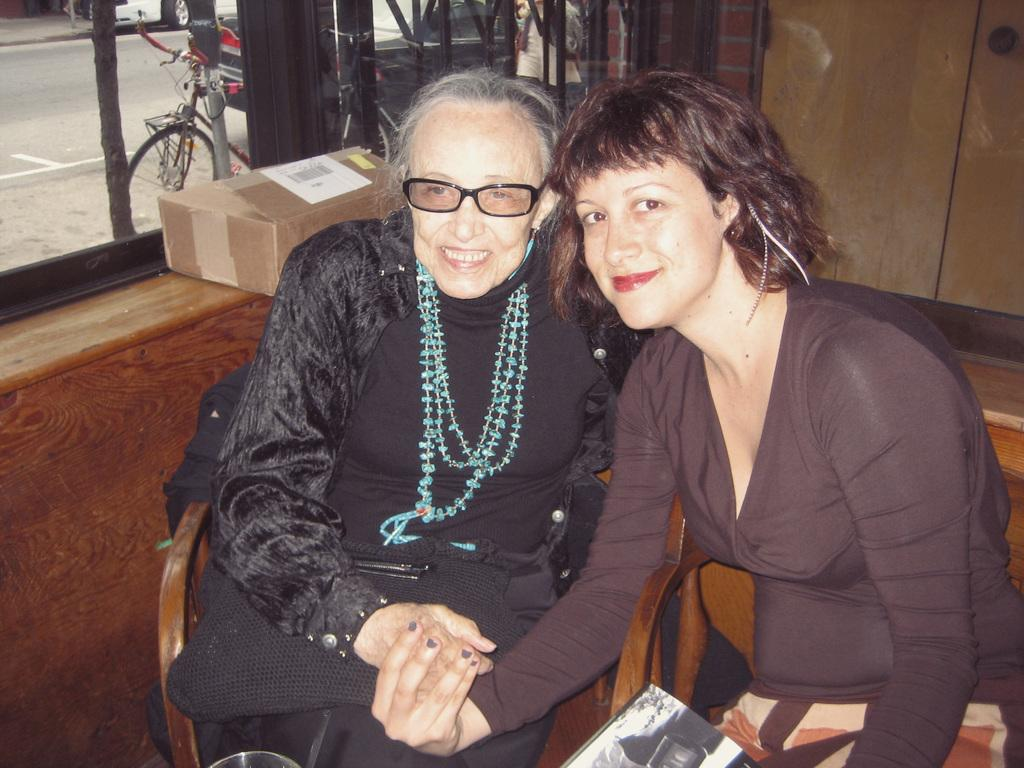How many women are in the image? There are two women in the foreground of the image. What is located behind the women? There is a cupboard behind the women. Where is the window in the image? The window is on the left side of the image. What can be seen outside the window? Vehicles are visible behind the window. What type of wrench is being used by one of the women in the image? There is no wrench present in the image; both women are simply standing in the foreground. Does the existence of the window in the image prove the existence of an alternate universe? The presence of a window in the image does not prove the existence of an alternate universe, as it is a common feature in many rooms and buildings. 